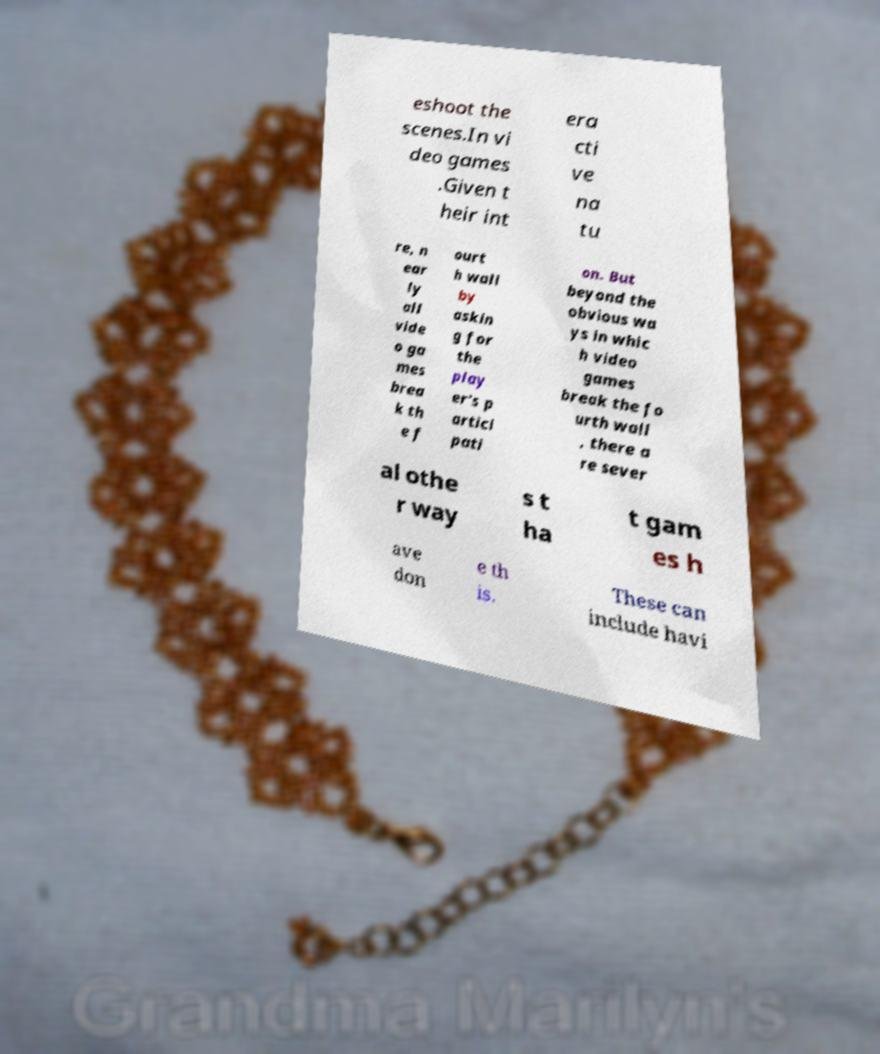For documentation purposes, I need the text within this image transcribed. Could you provide that? eshoot the scenes.In vi deo games .Given t heir int era cti ve na tu re, n ear ly all vide o ga mes brea k th e f ourt h wall by askin g for the play er's p artici pati on. But beyond the obvious wa ys in whic h video games break the fo urth wall , there a re sever al othe r way s t ha t gam es h ave don e th is. These can include havi 